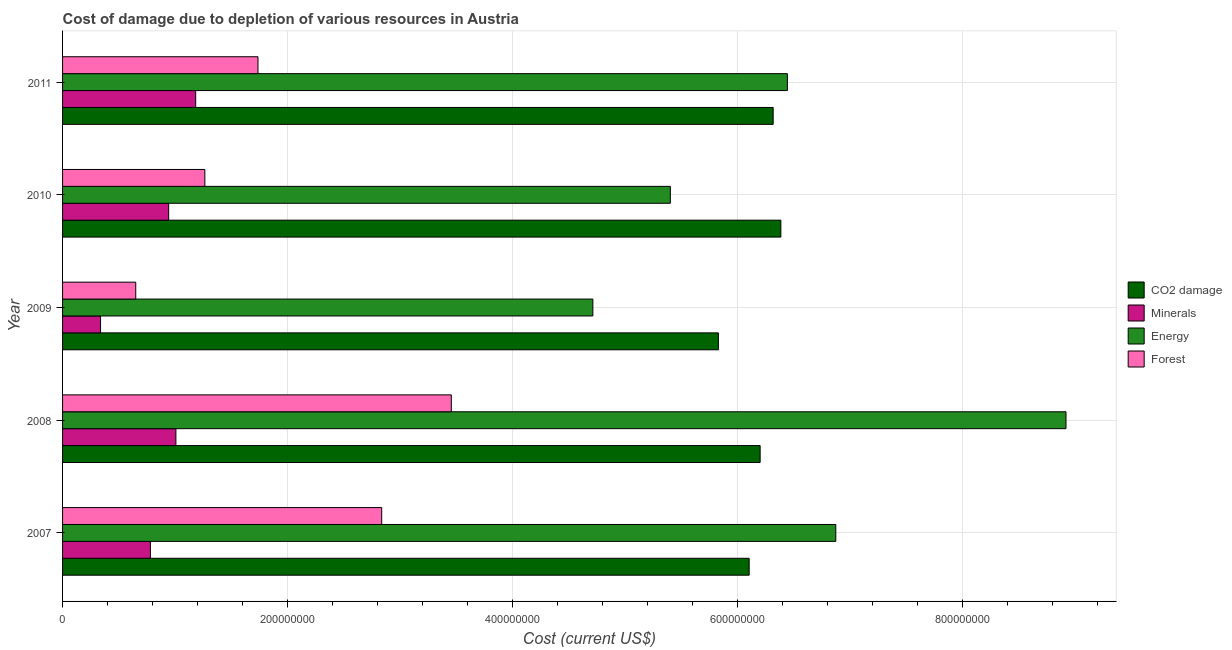How many bars are there on the 3rd tick from the top?
Ensure brevity in your answer.  4. What is the cost of damage due to depletion of coal in 2011?
Your answer should be very brief. 6.32e+08. Across all years, what is the maximum cost of damage due to depletion of forests?
Your response must be concise. 3.46e+08. Across all years, what is the minimum cost of damage due to depletion of forests?
Ensure brevity in your answer.  6.51e+07. In which year was the cost of damage due to depletion of forests minimum?
Offer a terse response. 2009. What is the total cost of damage due to depletion of minerals in the graph?
Offer a very short reply. 4.25e+08. What is the difference between the cost of damage due to depletion of forests in 2008 and that in 2011?
Offer a very short reply. 1.72e+08. What is the difference between the cost of damage due to depletion of coal in 2010 and the cost of damage due to depletion of energy in 2007?
Provide a succinct answer. -4.89e+07. What is the average cost of damage due to depletion of energy per year?
Make the answer very short. 6.47e+08. In the year 2008, what is the difference between the cost of damage due to depletion of coal and cost of damage due to depletion of energy?
Give a very brief answer. -2.72e+08. What is the ratio of the cost of damage due to depletion of energy in 2010 to that in 2011?
Your answer should be compact. 0.84. What is the difference between the highest and the second highest cost of damage due to depletion of coal?
Give a very brief answer. 6.82e+06. What is the difference between the highest and the lowest cost of damage due to depletion of forests?
Give a very brief answer. 2.81e+08. What does the 3rd bar from the top in 2007 represents?
Your answer should be very brief. Minerals. What does the 2nd bar from the bottom in 2009 represents?
Offer a terse response. Minerals. Is it the case that in every year, the sum of the cost of damage due to depletion of coal and cost of damage due to depletion of minerals is greater than the cost of damage due to depletion of energy?
Your answer should be very brief. No. How many bars are there?
Your answer should be very brief. 20. Are all the bars in the graph horizontal?
Keep it short and to the point. Yes. How many years are there in the graph?
Provide a short and direct response. 5. What is the difference between two consecutive major ticks on the X-axis?
Give a very brief answer. 2.00e+08. Does the graph contain any zero values?
Make the answer very short. No. Does the graph contain grids?
Offer a terse response. Yes. How many legend labels are there?
Your answer should be very brief. 4. How are the legend labels stacked?
Ensure brevity in your answer.  Vertical. What is the title of the graph?
Provide a short and direct response. Cost of damage due to depletion of various resources in Austria . What is the label or title of the X-axis?
Keep it short and to the point. Cost (current US$). What is the Cost (current US$) in CO2 damage in 2007?
Provide a short and direct response. 6.11e+08. What is the Cost (current US$) in Minerals in 2007?
Your answer should be compact. 7.81e+07. What is the Cost (current US$) in Energy in 2007?
Ensure brevity in your answer.  6.88e+08. What is the Cost (current US$) of Forest in 2007?
Your response must be concise. 2.84e+08. What is the Cost (current US$) of CO2 damage in 2008?
Offer a terse response. 6.20e+08. What is the Cost (current US$) in Minerals in 2008?
Ensure brevity in your answer.  1.01e+08. What is the Cost (current US$) of Energy in 2008?
Give a very brief answer. 8.92e+08. What is the Cost (current US$) in Forest in 2008?
Provide a short and direct response. 3.46e+08. What is the Cost (current US$) of CO2 damage in 2009?
Provide a succinct answer. 5.83e+08. What is the Cost (current US$) of Minerals in 2009?
Your answer should be very brief. 3.38e+07. What is the Cost (current US$) of Energy in 2009?
Your response must be concise. 4.72e+08. What is the Cost (current US$) of Forest in 2009?
Your answer should be compact. 6.51e+07. What is the Cost (current US$) of CO2 damage in 2010?
Offer a very short reply. 6.39e+08. What is the Cost (current US$) of Minerals in 2010?
Give a very brief answer. 9.44e+07. What is the Cost (current US$) in Energy in 2010?
Provide a succinct answer. 5.41e+08. What is the Cost (current US$) of Forest in 2010?
Keep it short and to the point. 1.27e+08. What is the Cost (current US$) in CO2 damage in 2011?
Ensure brevity in your answer.  6.32e+08. What is the Cost (current US$) of Minerals in 2011?
Keep it short and to the point. 1.18e+08. What is the Cost (current US$) of Energy in 2011?
Ensure brevity in your answer.  6.45e+08. What is the Cost (current US$) of Forest in 2011?
Offer a very short reply. 1.74e+08. Across all years, what is the maximum Cost (current US$) of CO2 damage?
Provide a short and direct response. 6.39e+08. Across all years, what is the maximum Cost (current US$) in Minerals?
Make the answer very short. 1.18e+08. Across all years, what is the maximum Cost (current US$) in Energy?
Offer a very short reply. 8.92e+08. Across all years, what is the maximum Cost (current US$) of Forest?
Your response must be concise. 3.46e+08. Across all years, what is the minimum Cost (current US$) of CO2 damage?
Give a very brief answer. 5.83e+08. Across all years, what is the minimum Cost (current US$) in Minerals?
Offer a terse response. 3.38e+07. Across all years, what is the minimum Cost (current US$) of Energy?
Provide a succinct answer. 4.72e+08. Across all years, what is the minimum Cost (current US$) in Forest?
Give a very brief answer. 6.51e+07. What is the total Cost (current US$) in CO2 damage in the graph?
Give a very brief answer. 3.09e+09. What is the total Cost (current US$) of Minerals in the graph?
Keep it short and to the point. 4.25e+08. What is the total Cost (current US$) of Energy in the graph?
Your answer should be compact. 3.24e+09. What is the total Cost (current US$) in Forest in the graph?
Give a very brief answer. 9.95e+08. What is the difference between the Cost (current US$) of CO2 damage in 2007 and that in 2008?
Provide a short and direct response. -9.76e+06. What is the difference between the Cost (current US$) in Minerals in 2007 and that in 2008?
Give a very brief answer. -2.27e+07. What is the difference between the Cost (current US$) of Energy in 2007 and that in 2008?
Make the answer very short. -2.05e+08. What is the difference between the Cost (current US$) in Forest in 2007 and that in 2008?
Give a very brief answer. -6.19e+07. What is the difference between the Cost (current US$) in CO2 damage in 2007 and that in 2009?
Your answer should be compact. 2.74e+07. What is the difference between the Cost (current US$) in Minerals in 2007 and that in 2009?
Offer a terse response. 4.43e+07. What is the difference between the Cost (current US$) in Energy in 2007 and that in 2009?
Your response must be concise. 2.16e+08. What is the difference between the Cost (current US$) in Forest in 2007 and that in 2009?
Offer a terse response. 2.19e+08. What is the difference between the Cost (current US$) of CO2 damage in 2007 and that in 2010?
Keep it short and to the point. -2.82e+07. What is the difference between the Cost (current US$) in Minerals in 2007 and that in 2010?
Your answer should be very brief. -1.63e+07. What is the difference between the Cost (current US$) in Energy in 2007 and that in 2010?
Offer a very short reply. 1.47e+08. What is the difference between the Cost (current US$) of Forest in 2007 and that in 2010?
Make the answer very short. 1.57e+08. What is the difference between the Cost (current US$) of CO2 damage in 2007 and that in 2011?
Provide a short and direct response. -2.13e+07. What is the difference between the Cost (current US$) of Minerals in 2007 and that in 2011?
Your answer should be compact. -4.03e+07. What is the difference between the Cost (current US$) of Energy in 2007 and that in 2011?
Keep it short and to the point. 4.31e+07. What is the difference between the Cost (current US$) in Forest in 2007 and that in 2011?
Keep it short and to the point. 1.10e+08. What is the difference between the Cost (current US$) in CO2 damage in 2008 and that in 2009?
Your answer should be very brief. 3.71e+07. What is the difference between the Cost (current US$) in Minerals in 2008 and that in 2009?
Offer a very short reply. 6.70e+07. What is the difference between the Cost (current US$) of Energy in 2008 and that in 2009?
Your response must be concise. 4.21e+08. What is the difference between the Cost (current US$) of Forest in 2008 and that in 2009?
Provide a succinct answer. 2.81e+08. What is the difference between the Cost (current US$) of CO2 damage in 2008 and that in 2010?
Provide a succinct answer. -1.84e+07. What is the difference between the Cost (current US$) of Minerals in 2008 and that in 2010?
Your answer should be very brief. 6.42e+06. What is the difference between the Cost (current US$) of Energy in 2008 and that in 2010?
Provide a short and direct response. 3.52e+08. What is the difference between the Cost (current US$) of Forest in 2008 and that in 2010?
Your answer should be very brief. 2.19e+08. What is the difference between the Cost (current US$) in CO2 damage in 2008 and that in 2011?
Provide a short and direct response. -1.16e+07. What is the difference between the Cost (current US$) in Minerals in 2008 and that in 2011?
Give a very brief answer. -1.76e+07. What is the difference between the Cost (current US$) in Energy in 2008 and that in 2011?
Your response must be concise. 2.48e+08. What is the difference between the Cost (current US$) in Forest in 2008 and that in 2011?
Provide a short and direct response. 1.72e+08. What is the difference between the Cost (current US$) in CO2 damage in 2009 and that in 2010?
Your answer should be compact. -5.55e+07. What is the difference between the Cost (current US$) of Minerals in 2009 and that in 2010?
Provide a short and direct response. -6.06e+07. What is the difference between the Cost (current US$) in Energy in 2009 and that in 2010?
Ensure brevity in your answer.  -6.89e+07. What is the difference between the Cost (current US$) in Forest in 2009 and that in 2010?
Your response must be concise. -6.14e+07. What is the difference between the Cost (current US$) of CO2 damage in 2009 and that in 2011?
Provide a succinct answer. -4.87e+07. What is the difference between the Cost (current US$) of Minerals in 2009 and that in 2011?
Make the answer very short. -8.46e+07. What is the difference between the Cost (current US$) in Energy in 2009 and that in 2011?
Provide a succinct answer. -1.73e+08. What is the difference between the Cost (current US$) of Forest in 2009 and that in 2011?
Your answer should be very brief. -1.09e+08. What is the difference between the Cost (current US$) of CO2 damage in 2010 and that in 2011?
Your answer should be compact. 6.82e+06. What is the difference between the Cost (current US$) of Minerals in 2010 and that in 2011?
Your answer should be compact. -2.40e+07. What is the difference between the Cost (current US$) of Energy in 2010 and that in 2011?
Offer a very short reply. -1.04e+08. What is the difference between the Cost (current US$) of Forest in 2010 and that in 2011?
Offer a terse response. -4.73e+07. What is the difference between the Cost (current US$) of CO2 damage in 2007 and the Cost (current US$) of Minerals in 2008?
Your response must be concise. 5.10e+08. What is the difference between the Cost (current US$) of CO2 damage in 2007 and the Cost (current US$) of Energy in 2008?
Offer a very short reply. -2.82e+08. What is the difference between the Cost (current US$) of CO2 damage in 2007 and the Cost (current US$) of Forest in 2008?
Keep it short and to the point. 2.65e+08. What is the difference between the Cost (current US$) of Minerals in 2007 and the Cost (current US$) of Energy in 2008?
Keep it short and to the point. -8.14e+08. What is the difference between the Cost (current US$) in Minerals in 2007 and the Cost (current US$) in Forest in 2008?
Offer a terse response. -2.68e+08. What is the difference between the Cost (current US$) in Energy in 2007 and the Cost (current US$) in Forest in 2008?
Provide a succinct answer. 3.42e+08. What is the difference between the Cost (current US$) of CO2 damage in 2007 and the Cost (current US$) of Minerals in 2009?
Your answer should be compact. 5.77e+08. What is the difference between the Cost (current US$) in CO2 damage in 2007 and the Cost (current US$) in Energy in 2009?
Give a very brief answer. 1.39e+08. What is the difference between the Cost (current US$) of CO2 damage in 2007 and the Cost (current US$) of Forest in 2009?
Offer a terse response. 5.46e+08. What is the difference between the Cost (current US$) in Minerals in 2007 and the Cost (current US$) in Energy in 2009?
Offer a terse response. -3.94e+08. What is the difference between the Cost (current US$) in Minerals in 2007 and the Cost (current US$) in Forest in 2009?
Your answer should be very brief. 1.30e+07. What is the difference between the Cost (current US$) in Energy in 2007 and the Cost (current US$) in Forest in 2009?
Make the answer very short. 6.23e+08. What is the difference between the Cost (current US$) of CO2 damage in 2007 and the Cost (current US$) of Minerals in 2010?
Make the answer very short. 5.16e+08. What is the difference between the Cost (current US$) in CO2 damage in 2007 and the Cost (current US$) in Energy in 2010?
Make the answer very short. 7.01e+07. What is the difference between the Cost (current US$) in CO2 damage in 2007 and the Cost (current US$) in Forest in 2010?
Your answer should be very brief. 4.84e+08. What is the difference between the Cost (current US$) in Minerals in 2007 and the Cost (current US$) in Energy in 2010?
Provide a short and direct response. -4.62e+08. What is the difference between the Cost (current US$) in Minerals in 2007 and the Cost (current US$) in Forest in 2010?
Provide a succinct answer. -4.84e+07. What is the difference between the Cost (current US$) in Energy in 2007 and the Cost (current US$) in Forest in 2010?
Offer a very short reply. 5.61e+08. What is the difference between the Cost (current US$) of CO2 damage in 2007 and the Cost (current US$) of Minerals in 2011?
Your answer should be very brief. 4.92e+08. What is the difference between the Cost (current US$) of CO2 damage in 2007 and the Cost (current US$) of Energy in 2011?
Provide a short and direct response. -3.40e+07. What is the difference between the Cost (current US$) of CO2 damage in 2007 and the Cost (current US$) of Forest in 2011?
Provide a short and direct response. 4.37e+08. What is the difference between the Cost (current US$) in Minerals in 2007 and the Cost (current US$) in Energy in 2011?
Your response must be concise. -5.67e+08. What is the difference between the Cost (current US$) of Minerals in 2007 and the Cost (current US$) of Forest in 2011?
Offer a very short reply. -9.57e+07. What is the difference between the Cost (current US$) of Energy in 2007 and the Cost (current US$) of Forest in 2011?
Give a very brief answer. 5.14e+08. What is the difference between the Cost (current US$) in CO2 damage in 2008 and the Cost (current US$) in Minerals in 2009?
Ensure brevity in your answer.  5.87e+08. What is the difference between the Cost (current US$) in CO2 damage in 2008 and the Cost (current US$) in Energy in 2009?
Your response must be concise. 1.49e+08. What is the difference between the Cost (current US$) of CO2 damage in 2008 and the Cost (current US$) of Forest in 2009?
Your response must be concise. 5.55e+08. What is the difference between the Cost (current US$) of Minerals in 2008 and the Cost (current US$) of Energy in 2009?
Your answer should be very brief. -3.71e+08. What is the difference between the Cost (current US$) in Minerals in 2008 and the Cost (current US$) in Forest in 2009?
Offer a terse response. 3.57e+07. What is the difference between the Cost (current US$) of Energy in 2008 and the Cost (current US$) of Forest in 2009?
Offer a terse response. 8.27e+08. What is the difference between the Cost (current US$) of CO2 damage in 2008 and the Cost (current US$) of Minerals in 2010?
Offer a very short reply. 5.26e+08. What is the difference between the Cost (current US$) in CO2 damage in 2008 and the Cost (current US$) in Energy in 2010?
Make the answer very short. 7.99e+07. What is the difference between the Cost (current US$) of CO2 damage in 2008 and the Cost (current US$) of Forest in 2010?
Offer a very short reply. 4.94e+08. What is the difference between the Cost (current US$) of Minerals in 2008 and the Cost (current US$) of Energy in 2010?
Offer a very short reply. -4.40e+08. What is the difference between the Cost (current US$) in Minerals in 2008 and the Cost (current US$) in Forest in 2010?
Offer a very short reply. -2.57e+07. What is the difference between the Cost (current US$) of Energy in 2008 and the Cost (current US$) of Forest in 2010?
Give a very brief answer. 7.66e+08. What is the difference between the Cost (current US$) in CO2 damage in 2008 and the Cost (current US$) in Minerals in 2011?
Give a very brief answer. 5.02e+08. What is the difference between the Cost (current US$) in CO2 damage in 2008 and the Cost (current US$) in Energy in 2011?
Provide a succinct answer. -2.42e+07. What is the difference between the Cost (current US$) of CO2 damage in 2008 and the Cost (current US$) of Forest in 2011?
Keep it short and to the point. 4.47e+08. What is the difference between the Cost (current US$) of Minerals in 2008 and the Cost (current US$) of Energy in 2011?
Your answer should be very brief. -5.44e+08. What is the difference between the Cost (current US$) of Minerals in 2008 and the Cost (current US$) of Forest in 2011?
Your answer should be compact. -7.30e+07. What is the difference between the Cost (current US$) of Energy in 2008 and the Cost (current US$) of Forest in 2011?
Keep it short and to the point. 7.19e+08. What is the difference between the Cost (current US$) in CO2 damage in 2009 and the Cost (current US$) in Minerals in 2010?
Provide a short and direct response. 4.89e+08. What is the difference between the Cost (current US$) in CO2 damage in 2009 and the Cost (current US$) in Energy in 2010?
Offer a very short reply. 4.27e+07. What is the difference between the Cost (current US$) in CO2 damage in 2009 and the Cost (current US$) in Forest in 2010?
Your answer should be compact. 4.57e+08. What is the difference between the Cost (current US$) of Minerals in 2009 and the Cost (current US$) of Energy in 2010?
Offer a very short reply. -5.07e+08. What is the difference between the Cost (current US$) in Minerals in 2009 and the Cost (current US$) in Forest in 2010?
Your response must be concise. -9.28e+07. What is the difference between the Cost (current US$) in Energy in 2009 and the Cost (current US$) in Forest in 2010?
Give a very brief answer. 3.45e+08. What is the difference between the Cost (current US$) in CO2 damage in 2009 and the Cost (current US$) in Minerals in 2011?
Your answer should be very brief. 4.65e+08. What is the difference between the Cost (current US$) in CO2 damage in 2009 and the Cost (current US$) in Energy in 2011?
Your answer should be very brief. -6.14e+07. What is the difference between the Cost (current US$) in CO2 damage in 2009 and the Cost (current US$) in Forest in 2011?
Offer a very short reply. 4.09e+08. What is the difference between the Cost (current US$) of Minerals in 2009 and the Cost (current US$) of Energy in 2011?
Offer a terse response. -6.11e+08. What is the difference between the Cost (current US$) of Minerals in 2009 and the Cost (current US$) of Forest in 2011?
Provide a succinct answer. -1.40e+08. What is the difference between the Cost (current US$) in Energy in 2009 and the Cost (current US$) in Forest in 2011?
Your answer should be compact. 2.98e+08. What is the difference between the Cost (current US$) in CO2 damage in 2010 and the Cost (current US$) in Minerals in 2011?
Provide a succinct answer. 5.20e+08. What is the difference between the Cost (current US$) in CO2 damage in 2010 and the Cost (current US$) in Energy in 2011?
Keep it short and to the point. -5.82e+06. What is the difference between the Cost (current US$) of CO2 damage in 2010 and the Cost (current US$) of Forest in 2011?
Keep it short and to the point. 4.65e+08. What is the difference between the Cost (current US$) of Minerals in 2010 and the Cost (current US$) of Energy in 2011?
Make the answer very short. -5.50e+08. What is the difference between the Cost (current US$) of Minerals in 2010 and the Cost (current US$) of Forest in 2011?
Offer a terse response. -7.94e+07. What is the difference between the Cost (current US$) of Energy in 2010 and the Cost (current US$) of Forest in 2011?
Offer a very short reply. 3.67e+08. What is the average Cost (current US$) of CO2 damage per year?
Ensure brevity in your answer.  6.17e+08. What is the average Cost (current US$) of Minerals per year?
Your answer should be compact. 8.51e+07. What is the average Cost (current US$) of Energy per year?
Make the answer very short. 6.47e+08. What is the average Cost (current US$) of Forest per year?
Provide a succinct answer. 1.99e+08. In the year 2007, what is the difference between the Cost (current US$) of CO2 damage and Cost (current US$) of Minerals?
Your answer should be compact. 5.33e+08. In the year 2007, what is the difference between the Cost (current US$) of CO2 damage and Cost (current US$) of Energy?
Ensure brevity in your answer.  -7.70e+07. In the year 2007, what is the difference between the Cost (current US$) of CO2 damage and Cost (current US$) of Forest?
Your answer should be compact. 3.27e+08. In the year 2007, what is the difference between the Cost (current US$) in Minerals and Cost (current US$) in Energy?
Provide a short and direct response. -6.10e+08. In the year 2007, what is the difference between the Cost (current US$) in Minerals and Cost (current US$) in Forest?
Give a very brief answer. -2.06e+08. In the year 2007, what is the difference between the Cost (current US$) of Energy and Cost (current US$) of Forest?
Offer a terse response. 4.04e+08. In the year 2008, what is the difference between the Cost (current US$) in CO2 damage and Cost (current US$) in Minerals?
Your answer should be compact. 5.20e+08. In the year 2008, what is the difference between the Cost (current US$) of CO2 damage and Cost (current US$) of Energy?
Make the answer very short. -2.72e+08. In the year 2008, what is the difference between the Cost (current US$) in CO2 damage and Cost (current US$) in Forest?
Make the answer very short. 2.75e+08. In the year 2008, what is the difference between the Cost (current US$) in Minerals and Cost (current US$) in Energy?
Provide a short and direct response. -7.92e+08. In the year 2008, what is the difference between the Cost (current US$) in Minerals and Cost (current US$) in Forest?
Keep it short and to the point. -2.45e+08. In the year 2008, what is the difference between the Cost (current US$) in Energy and Cost (current US$) in Forest?
Ensure brevity in your answer.  5.47e+08. In the year 2009, what is the difference between the Cost (current US$) in CO2 damage and Cost (current US$) in Minerals?
Give a very brief answer. 5.50e+08. In the year 2009, what is the difference between the Cost (current US$) of CO2 damage and Cost (current US$) of Energy?
Provide a short and direct response. 1.12e+08. In the year 2009, what is the difference between the Cost (current US$) of CO2 damage and Cost (current US$) of Forest?
Offer a very short reply. 5.18e+08. In the year 2009, what is the difference between the Cost (current US$) of Minerals and Cost (current US$) of Energy?
Offer a very short reply. -4.38e+08. In the year 2009, what is the difference between the Cost (current US$) in Minerals and Cost (current US$) in Forest?
Provide a short and direct response. -3.13e+07. In the year 2009, what is the difference between the Cost (current US$) of Energy and Cost (current US$) of Forest?
Keep it short and to the point. 4.07e+08. In the year 2010, what is the difference between the Cost (current US$) in CO2 damage and Cost (current US$) in Minerals?
Your answer should be very brief. 5.44e+08. In the year 2010, what is the difference between the Cost (current US$) of CO2 damage and Cost (current US$) of Energy?
Your response must be concise. 9.83e+07. In the year 2010, what is the difference between the Cost (current US$) in CO2 damage and Cost (current US$) in Forest?
Provide a short and direct response. 5.12e+08. In the year 2010, what is the difference between the Cost (current US$) in Minerals and Cost (current US$) in Energy?
Your response must be concise. -4.46e+08. In the year 2010, what is the difference between the Cost (current US$) of Minerals and Cost (current US$) of Forest?
Offer a very short reply. -3.22e+07. In the year 2010, what is the difference between the Cost (current US$) of Energy and Cost (current US$) of Forest?
Give a very brief answer. 4.14e+08. In the year 2011, what is the difference between the Cost (current US$) in CO2 damage and Cost (current US$) in Minerals?
Offer a terse response. 5.14e+08. In the year 2011, what is the difference between the Cost (current US$) in CO2 damage and Cost (current US$) in Energy?
Your answer should be compact. -1.26e+07. In the year 2011, what is the difference between the Cost (current US$) of CO2 damage and Cost (current US$) of Forest?
Keep it short and to the point. 4.58e+08. In the year 2011, what is the difference between the Cost (current US$) in Minerals and Cost (current US$) in Energy?
Provide a short and direct response. -5.26e+08. In the year 2011, what is the difference between the Cost (current US$) of Minerals and Cost (current US$) of Forest?
Make the answer very short. -5.54e+07. In the year 2011, what is the difference between the Cost (current US$) of Energy and Cost (current US$) of Forest?
Your answer should be very brief. 4.71e+08. What is the ratio of the Cost (current US$) in CO2 damage in 2007 to that in 2008?
Give a very brief answer. 0.98. What is the ratio of the Cost (current US$) of Minerals in 2007 to that in 2008?
Give a very brief answer. 0.78. What is the ratio of the Cost (current US$) in Energy in 2007 to that in 2008?
Give a very brief answer. 0.77. What is the ratio of the Cost (current US$) of Forest in 2007 to that in 2008?
Make the answer very short. 0.82. What is the ratio of the Cost (current US$) in CO2 damage in 2007 to that in 2009?
Make the answer very short. 1.05. What is the ratio of the Cost (current US$) in Minerals in 2007 to that in 2009?
Your answer should be very brief. 2.31. What is the ratio of the Cost (current US$) in Energy in 2007 to that in 2009?
Your answer should be very brief. 1.46. What is the ratio of the Cost (current US$) in Forest in 2007 to that in 2009?
Offer a terse response. 4.36. What is the ratio of the Cost (current US$) in CO2 damage in 2007 to that in 2010?
Your answer should be compact. 0.96. What is the ratio of the Cost (current US$) in Minerals in 2007 to that in 2010?
Your answer should be very brief. 0.83. What is the ratio of the Cost (current US$) in Energy in 2007 to that in 2010?
Provide a succinct answer. 1.27. What is the ratio of the Cost (current US$) in Forest in 2007 to that in 2010?
Offer a terse response. 2.24. What is the ratio of the Cost (current US$) of CO2 damage in 2007 to that in 2011?
Give a very brief answer. 0.97. What is the ratio of the Cost (current US$) of Minerals in 2007 to that in 2011?
Ensure brevity in your answer.  0.66. What is the ratio of the Cost (current US$) in Energy in 2007 to that in 2011?
Provide a short and direct response. 1.07. What is the ratio of the Cost (current US$) in Forest in 2007 to that in 2011?
Make the answer very short. 1.63. What is the ratio of the Cost (current US$) of CO2 damage in 2008 to that in 2009?
Provide a short and direct response. 1.06. What is the ratio of the Cost (current US$) in Minerals in 2008 to that in 2009?
Keep it short and to the point. 2.98. What is the ratio of the Cost (current US$) in Energy in 2008 to that in 2009?
Offer a very short reply. 1.89. What is the ratio of the Cost (current US$) of Forest in 2008 to that in 2009?
Provide a short and direct response. 5.31. What is the ratio of the Cost (current US$) of CO2 damage in 2008 to that in 2010?
Give a very brief answer. 0.97. What is the ratio of the Cost (current US$) of Minerals in 2008 to that in 2010?
Your response must be concise. 1.07. What is the ratio of the Cost (current US$) in Energy in 2008 to that in 2010?
Your response must be concise. 1.65. What is the ratio of the Cost (current US$) of Forest in 2008 to that in 2010?
Your response must be concise. 2.73. What is the ratio of the Cost (current US$) of CO2 damage in 2008 to that in 2011?
Keep it short and to the point. 0.98. What is the ratio of the Cost (current US$) of Minerals in 2008 to that in 2011?
Your response must be concise. 0.85. What is the ratio of the Cost (current US$) of Energy in 2008 to that in 2011?
Your answer should be compact. 1.38. What is the ratio of the Cost (current US$) of Forest in 2008 to that in 2011?
Provide a succinct answer. 1.99. What is the ratio of the Cost (current US$) in CO2 damage in 2009 to that in 2010?
Your answer should be compact. 0.91. What is the ratio of the Cost (current US$) in Minerals in 2009 to that in 2010?
Provide a succinct answer. 0.36. What is the ratio of the Cost (current US$) of Energy in 2009 to that in 2010?
Your response must be concise. 0.87. What is the ratio of the Cost (current US$) of Forest in 2009 to that in 2010?
Keep it short and to the point. 0.51. What is the ratio of the Cost (current US$) of CO2 damage in 2009 to that in 2011?
Give a very brief answer. 0.92. What is the ratio of the Cost (current US$) in Minerals in 2009 to that in 2011?
Your response must be concise. 0.29. What is the ratio of the Cost (current US$) of Energy in 2009 to that in 2011?
Provide a succinct answer. 0.73. What is the ratio of the Cost (current US$) in Forest in 2009 to that in 2011?
Make the answer very short. 0.37. What is the ratio of the Cost (current US$) in CO2 damage in 2010 to that in 2011?
Offer a very short reply. 1.01. What is the ratio of the Cost (current US$) of Minerals in 2010 to that in 2011?
Provide a succinct answer. 0.8. What is the ratio of the Cost (current US$) in Energy in 2010 to that in 2011?
Offer a very short reply. 0.84. What is the ratio of the Cost (current US$) of Forest in 2010 to that in 2011?
Your answer should be compact. 0.73. What is the difference between the highest and the second highest Cost (current US$) in CO2 damage?
Your answer should be very brief. 6.82e+06. What is the difference between the highest and the second highest Cost (current US$) of Minerals?
Your answer should be very brief. 1.76e+07. What is the difference between the highest and the second highest Cost (current US$) of Energy?
Your answer should be compact. 2.05e+08. What is the difference between the highest and the second highest Cost (current US$) in Forest?
Your response must be concise. 6.19e+07. What is the difference between the highest and the lowest Cost (current US$) in CO2 damage?
Your response must be concise. 5.55e+07. What is the difference between the highest and the lowest Cost (current US$) of Minerals?
Offer a terse response. 8.46e+07. What is the difference between the highest and the lowest Cost (current US$) of Energy?
Your answer should be very brief. 4.21e+08. What is the difference between the highest and the lowest Cost (current US$) in Forest?
Offer a terse response. 2.81e+08. 